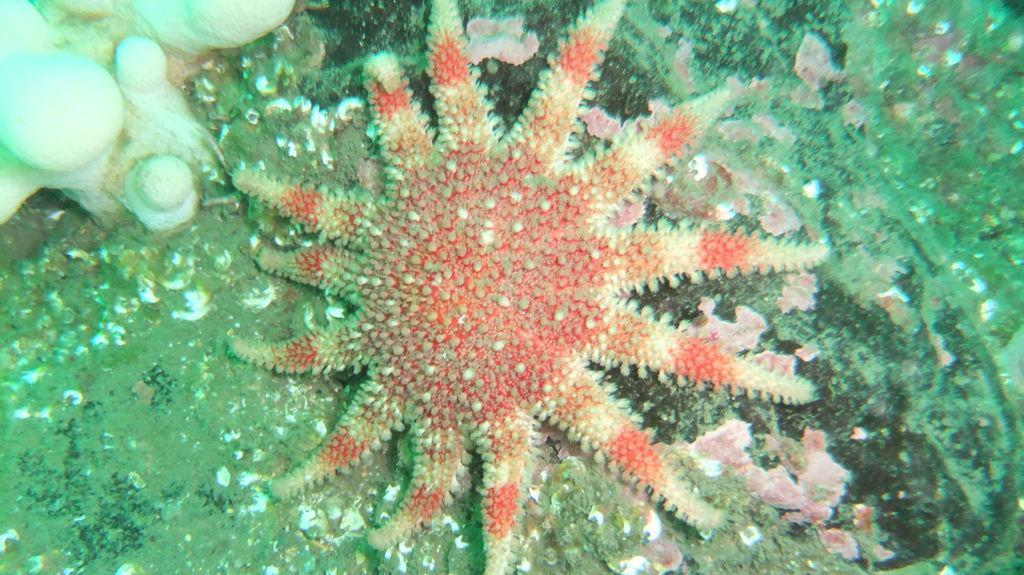Could you give a brief overview of what you see in this image? As we can see in the image there is a flower. 